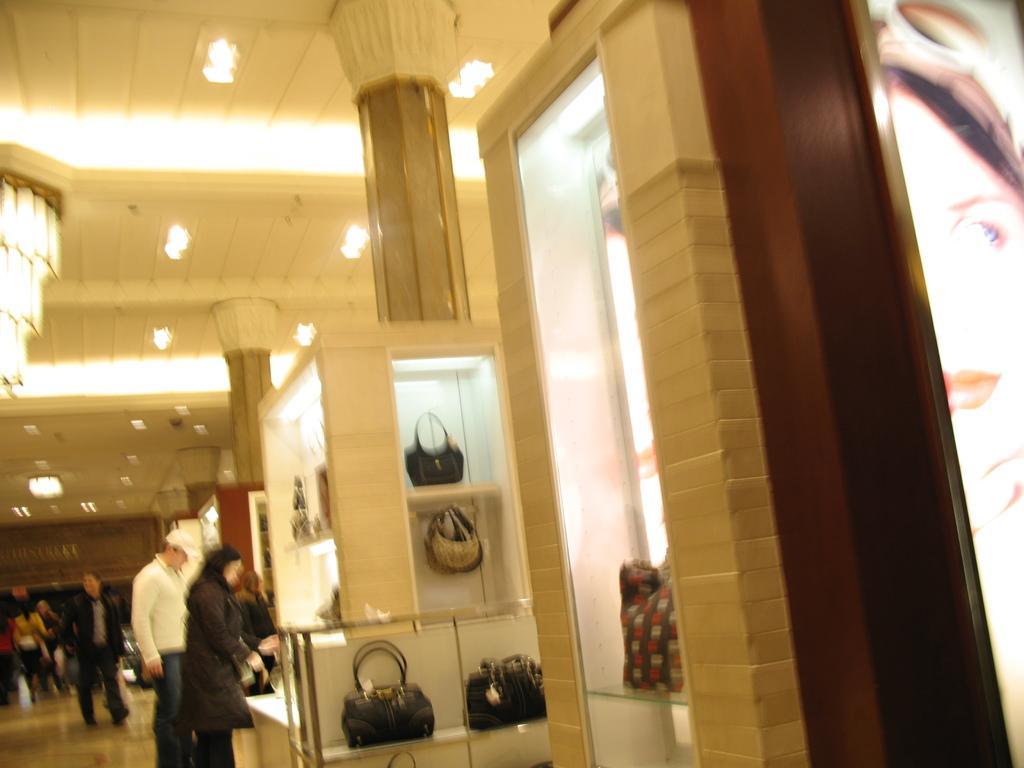Can you describe this image briefly? It is a blur image. Here we can see few people, handbags, glass, wall, banner. Here there are few pillars, chandelier, ceiling with lights. 